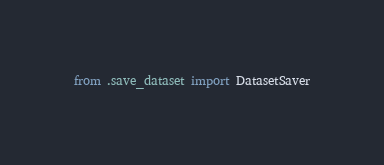<code> <loc_0><loc_0><loc_500><loc_500><_Python_>from .save_dataset import DatasetSaver</code> 